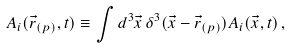Convert formula to latex. <formula><loc_0><loc_0><loc_500><loc_500>A _ { i } ( \vec { r } _ { ( p ) } , t ) \equiv \int d ^ { 3 } \vec { x } \, \delta ^ { 3 } ( \vec { x } - \vec { r } _ { ( p ) } ) A _ { i } ( \vec { x } , t ) \, ,</formula> 